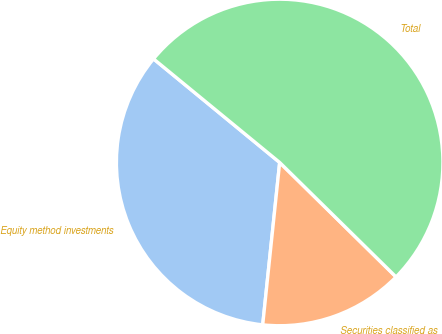<chart> <loc_0><loc_0><loc_500><loc_500><pie_chart><fcel>Equity method investments<fcel>Securities classified as<fcel>Total<nl><fcel>34.29%<fcel>14.29%<fcel>51.43%<nl></chart> 